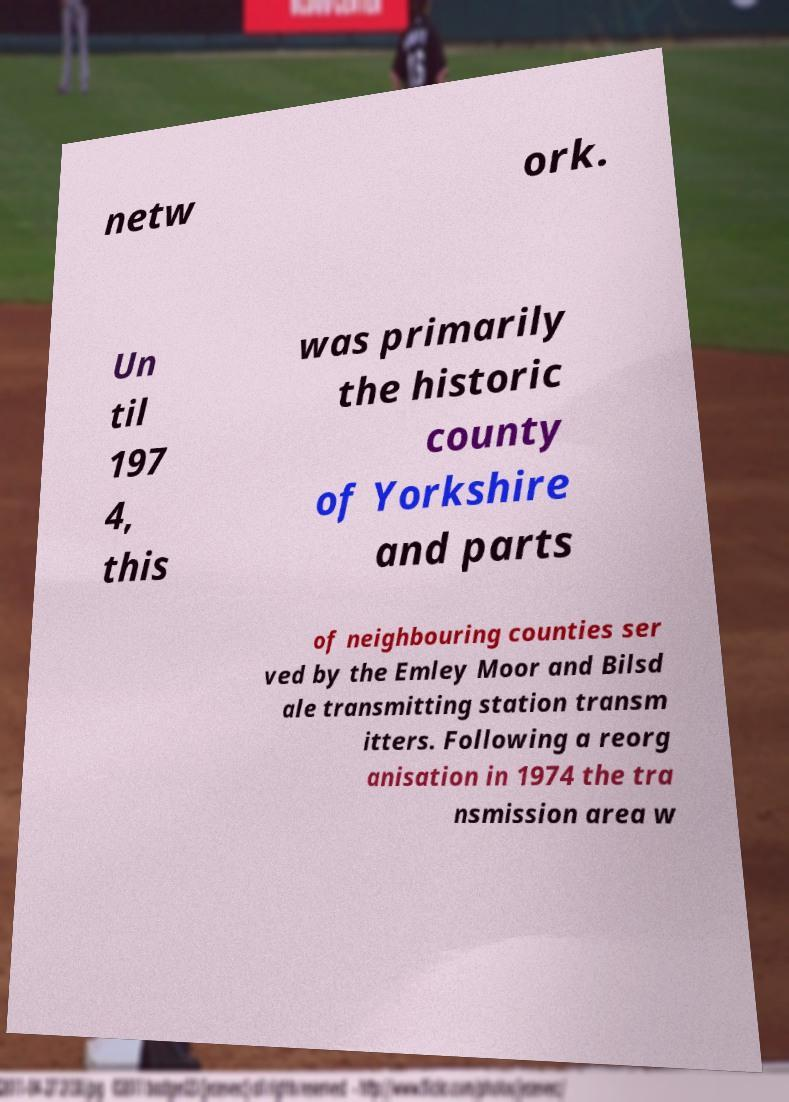There's text embedded in this image that I need extracted. Can you transcribe it verbatim? netw ork. Un til 197 4, this was primarily the historic county of Yorkshire and parts of neighbouring counties ser ved by the Emley Moor and Bilsd ale transmitting station transm itters. Following a reorg anisation in 1974 the tra nsmission area w 